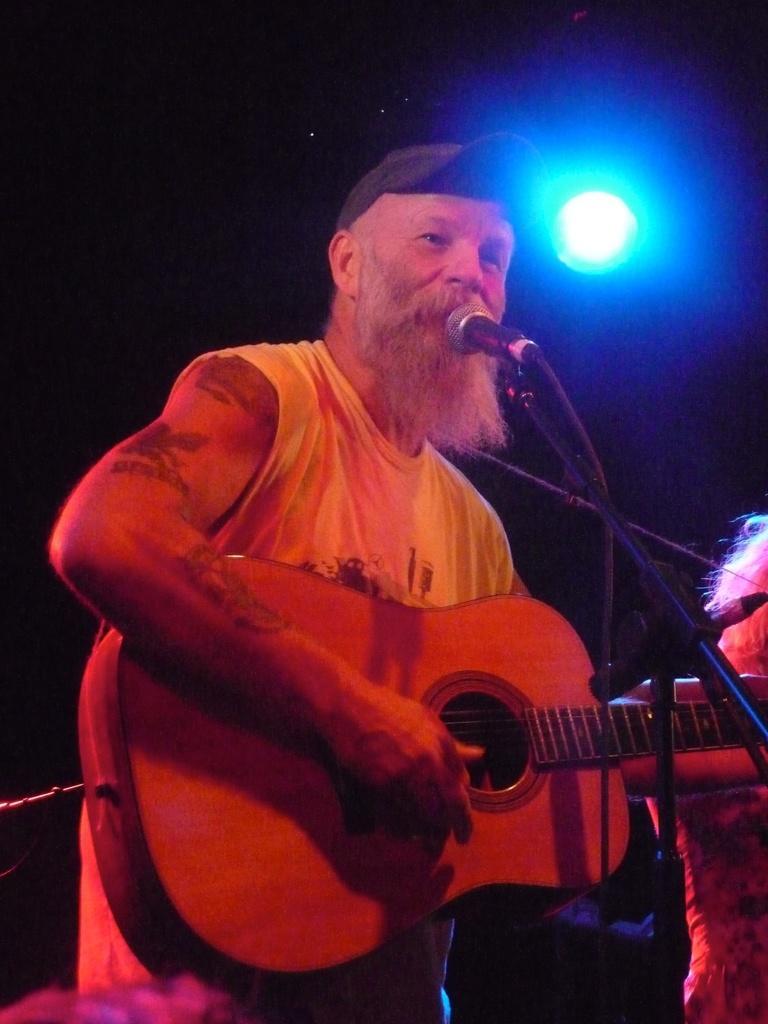Can you describe this image briefly? In this image there is a person standing and playing guitar. In the front there is a microphone at the back there is another person. At the top there is a light. 